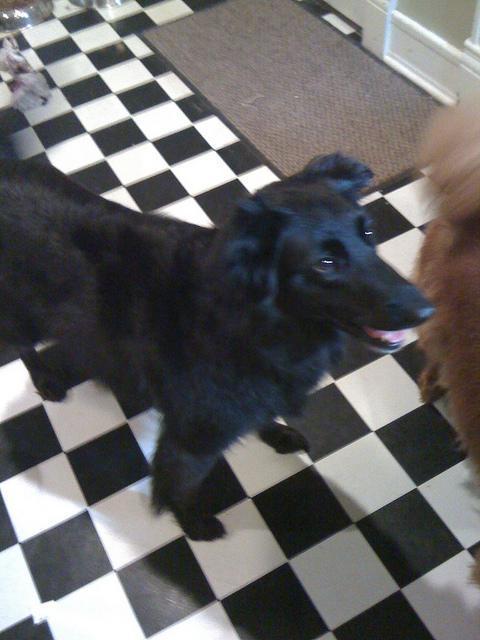How many dogs are there?
Give a very brief answer. 2. 